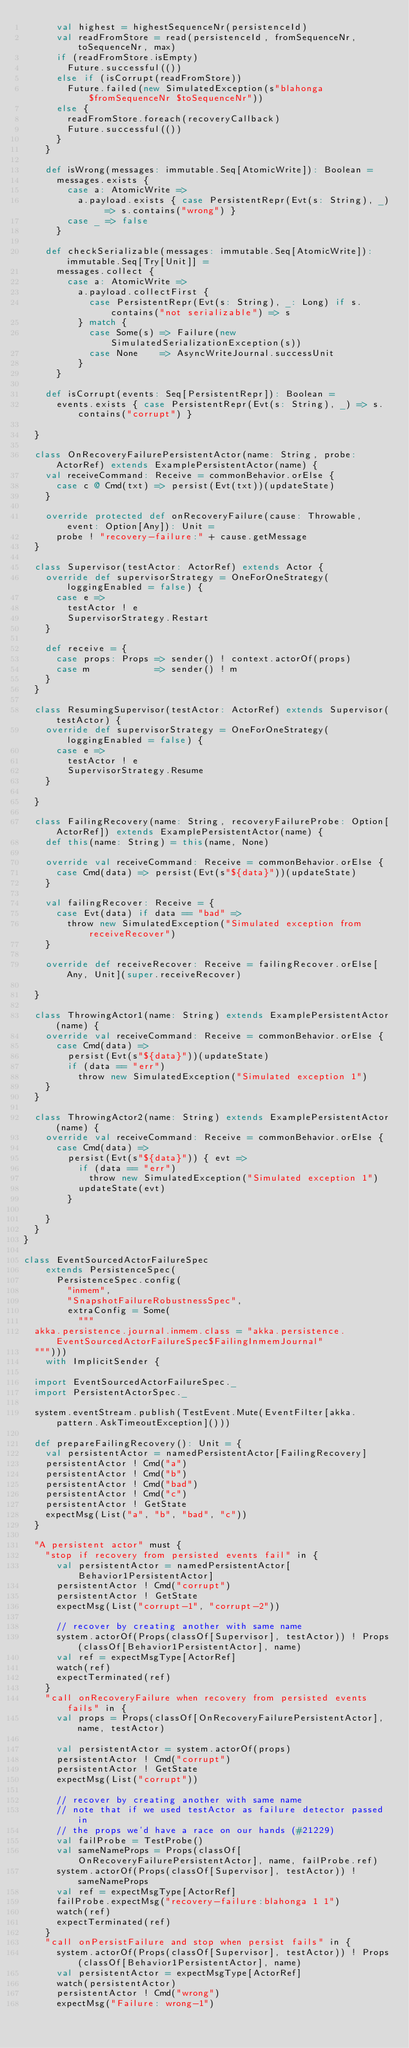<code> <loc_0><loc_0><loc_500><loc_500><_Scala_>      val highest = highestSequenceNr(persistenceId)
      val readFromStore = read(persistenceId, fromSequenceNr, toSequenceNr, max)
      if (readFromStore.isEmpty)
        Future.successful(())
      else if (isCorrupt(readFromStore))
        Future.failed(new SimulatedException(s"blahonga $fromSequenceNr $toSequenceNr"))
      else {
        readFromStore.foreach(recoveryCallback)
        Future.successful(())
      }
    }

    def isWrong(messages: immutable.Seq[AtomicWrite]): Boolean =
      messages.exists {
        case a: AtomicWrite =>
          a.payload.exists { case PersistentRepr(Evt(s: String), _) => s.contains("wrong") }
        case _ => false
      }

    def checkSerializable(messages: immutable.Seq[AtomicWrite]): immutable.Seq[Try[Unit]] =
      messages.collect {
        case a: AtomicWrite =>
          a.payload.collectFirst {
            case PersistentRepr(Evt(s: String), _: Long) if s.contains("not serializable") => s
          } match {
            case Some(s) => Failure(new SimulatedSerializationException(s))
            case None    => AsyncWriteJournal.successUnit
          }
      }

    def isCorrupt(events: Seq[PersistentRepr]): Boolean =
      events.exists { case PersistentRepr(Evt(s: String), _) => s.contains("corrupt") }

  }

  class OnRecoveryFailurePersistentActor(name: String, probe: ActorRef) extends ExamplePersistentActor(name) {
    val receiveCommand: Receive = commonBehavior.orElse {
      case c @ Cmd(txt) => persist(Evt(txt))(updateState)
    }

    override protected def onRecoveryFailure(cause: Throwable, event: Option[Any]): Unit =
      probe ! "recovery-failure:" + cause.getMessage
  }

  class Supervisor(testActor: ActorRef) extends Actor {
    override def supervisorStrategy = OneForOneStrategy(loggingEnabled = false) {
      case e =>
        testActor ! e
        SupervisorStrategy.Restart
    }

    def receive = {
      case props: Props => sender() ! context.actorOf(props)
      case m            => sender() ! m
    }
  }

  class ResumingSupervisor(testActor: ActorRef) extends Supervisor(testActor) {
    override def supervisorStrategy = OneForOneStrategy(loggingEnabled = false) {
      case e =>
        testActor ! e
        SupervisorStrategy.Resume
    }

  }

  class FailingRecovery(name: String, recoveryFailureProbe: Option[ActorRef]) extends ExamplePersistentActor(name) {
    def this(name: String) = this(name, None)

    override val receiveCommand: Receive = commonBehavior.orElse {
      case Cmd(data) => persist(Evt(s"${data}"))(updateState)
    }

    val failingRecover: Receive = {
      case Evt(data) if data == "bad" =>
        throw new SimulatedException("Simulated exception from receiveRecover")
    }

    override def receiveRecover: Receive = failingRecover.orElse[Any, Unit](super.receiveRecover)

  }

  class ThrowingActor1(name: String) extends ExamplePersistentActor(name) {
    override val receiveCommand: Receive = commonBehavior.orElse {
      case Cmd(data) =>
        persist(Evt(s"${data}"))(updateState)
        if (data == "err")
          throw new SimulatedException("Simulated exception 1")
    }
  }

  class ThrowingActor2(name: String) extends ExamplePersistentActor(name) {
    override val receiveCommand: Receive = commonBehavior.orElse {
      case Cmd(data) =>
        persist(Evt(s"${data}")) { evt =>
          if (data == "err")
            throw new SimulatedException("Simulated exception 1")
          updateState(evt)
        }

    }
  }
}

class EventSourcedActorFailureSpec
    extends PersistenceSpec(
      PersistenceSpec.config(
        "inmem",
        "SnapshotFailureRobustnessSpec",
        extraConfig = Some(
          """
  akka.persistence.journal.inmem.class = "akka.persistence.EventSourcedActorFailureSpec$FailingInmemJournal"
  """)))
    with ImplicitSender {

  import EventSourcedActorFailureSpec._
  import PersistentActorSpec._

  system.eventStream.publish(TestEvent.Mute(EventFilter[akka.pattern.AskTimeoutException]()))

  def prepareFailingRecovery(): Unit = {
    val persistentActor = namedPersistentActor[FailingRecovery]
    persistentActor ! Cmd("a")
    persistentActor ! Cmd("b")
    persistentActor ! Cmd("bad")
    persistentActor ! Cmd("c")
    persistentActor ! GetState
    expectMsg(List("a", "b", "bad", "c"))
  }

  "A persistent actor" must {
    "stop if recovery from persisted events fail" in {
      val persistentActor = namedPersistentActor[Behavior1PersistentActor]
      persistentActor ! Cmd("corrupt")
      persistentActor ! GetState
      expectMsg(List("corrupt-1", "corrupt-2"))

      // recover by creating another with same name
      system.actorOf(Props(classOf[Supervisor], testActor)) ! Props(classOf[Behavior1PersistentActor], name)
      val ref = expectMsgType[ActorRef]
      watch(ref)
      expectTerminated(ref)
    }
    "call onRecoveryFailure when recovery from persisted events fails" in {
      val props = Props(classOf[OnRecoveryFailurePersistentActor], name, testActor)

      val persistentActor = system.actorOf(props)
      persistentActor ! Cmd("corrupt")
      persistentActor ! GetState
      expectMsg(List("corrupt"))

      // recover by creating another with same name
      // note that if we used testActor as failure detector passed in
      // the props we'd have a race on our hands (#21229)
      val failProbe = TestProbe()
      val sameNameProps = Props(classOf[OnRecoveryFailurePersistentActor], name, failProbe.ref)
      system.actorOf(Props(classOf[Supervisor], testActor)) ! sameNameProps
      val ref = expectMsgType[ActorRef]
      failProbe.expectMsg("recovery-failure:blahonga 1 1")
      watch(ref)
      expectTerminated(ref)
    }
    "call onPersistFailure and stop when persist fails" in {
      system.actorOf(Props(classOf[Supervisor], testActor)) ! Props(classOf[Behavior1PersistentActor], name)
      val persistentActor = expectMsgType[ActorRef]
      watch(persistentActor)
      persistentActor ! Cmd("wrong")
      expectMsg("Failure: wrong-1")</code> 